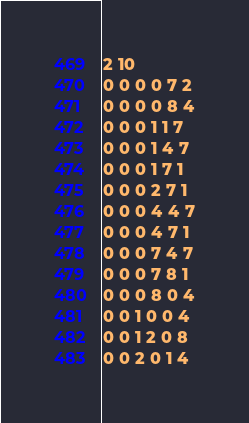Convert code to text. <code><loc_0><loc_0><loc_500><loc_500><_SQL_>2 10
0 0 0 0 7 2
0 0 0 0 8 4
0 0 0 1 1 7
0 0 0 1 4 7
0 0 0 1 7 1
0 0 0 2 7 1
0 0 0 4 4 7
0 0 0 4 7 1
0 0 0 7 4 7
0 0 0 7 8 1
0 0 0 8 0 4
0 0 1 0 0 4
0 0 1 2 0 8
0 0 2 0 1 4</code> 